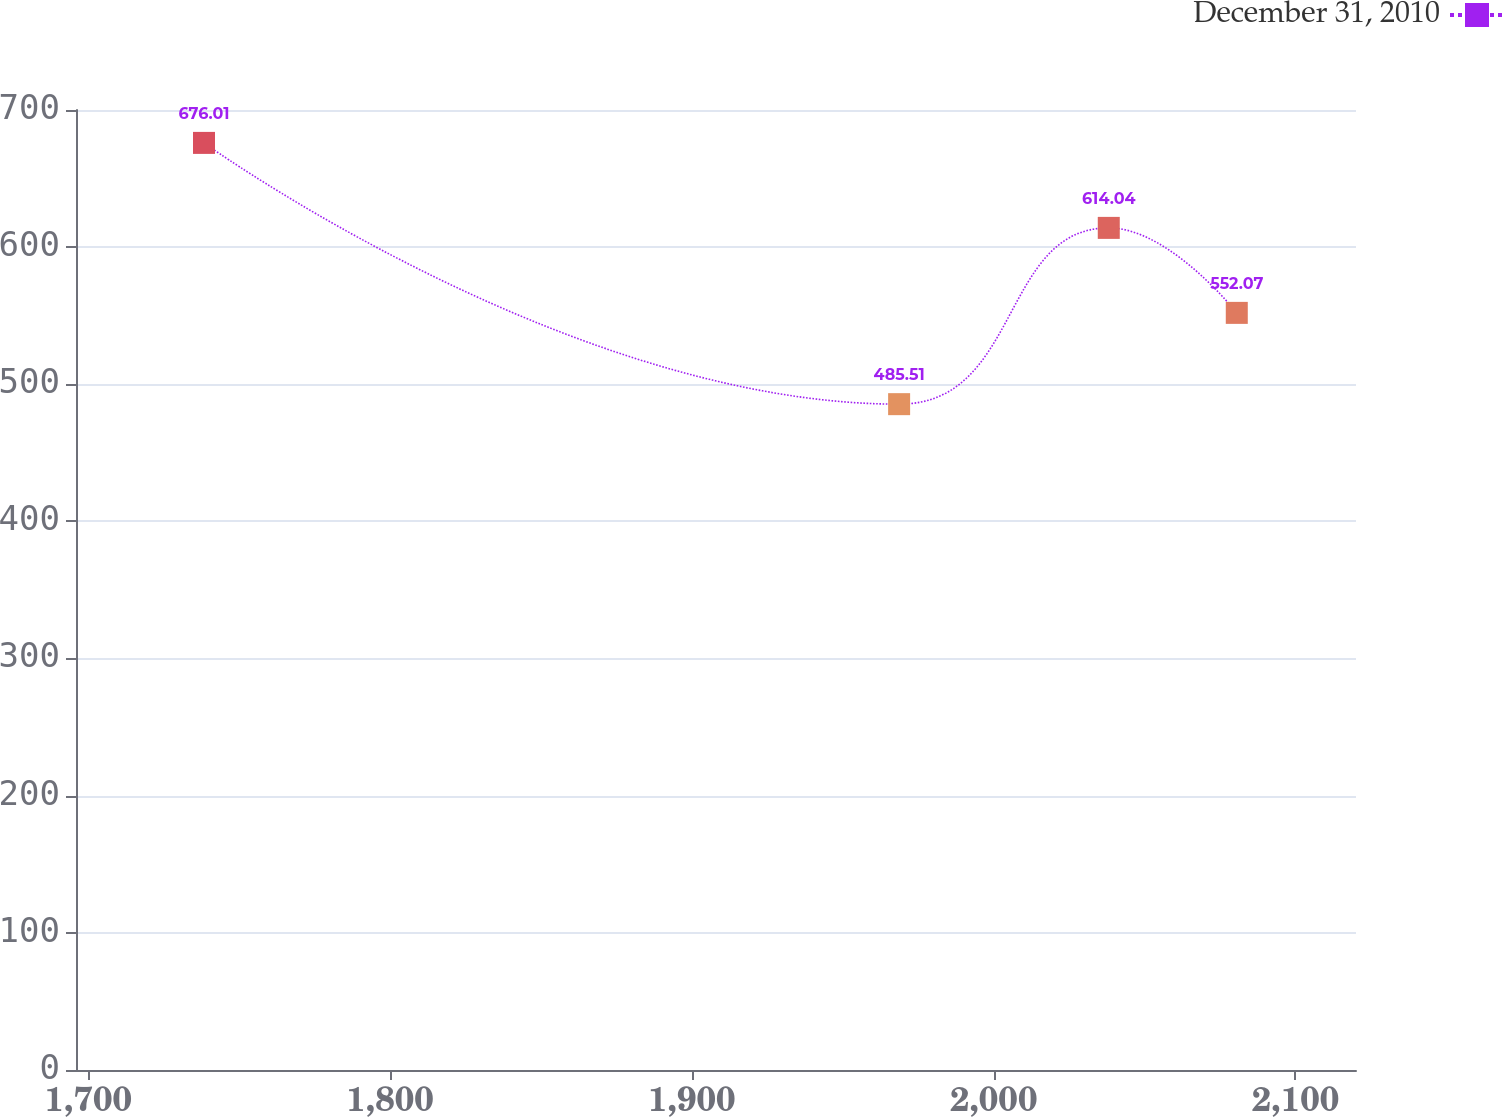<chart> <loc_0><loc_0><loc_500><loc_500><line_chart><ecel><fcel>December 31, 2010<nl><fcel>1738.34<fcel>676.01<nl><fcel>1968.68<fcel>485.51<nl><fcel>2038.15<fcel>614.04<nl><fcel>2080.57<fcel>552.07<nl><fcel>2162.49<fcel>1.16<nl></chart> 